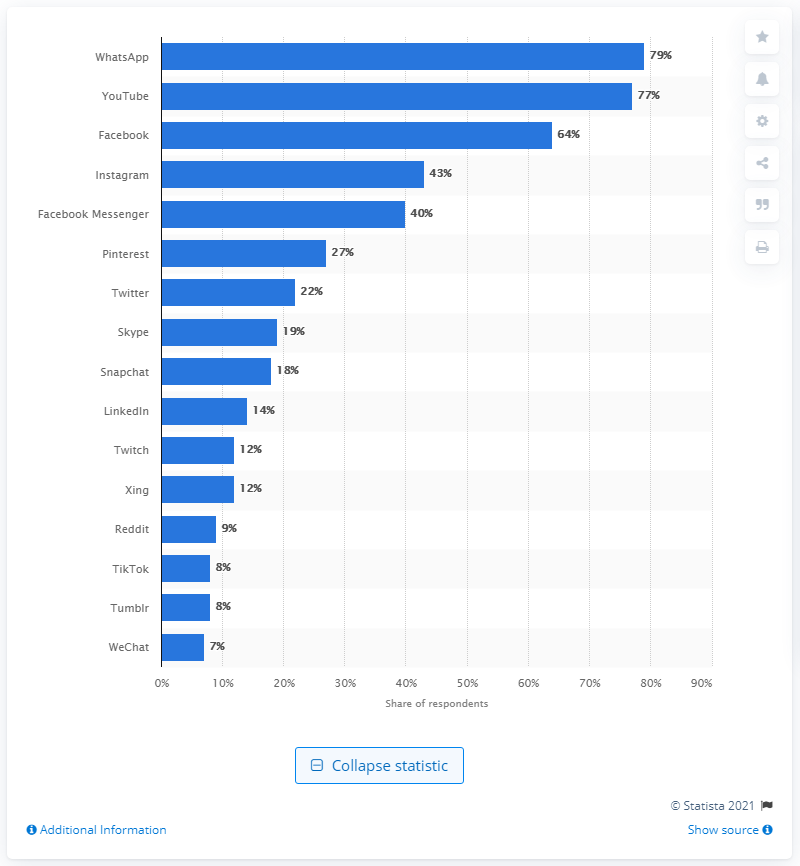Point out several critical features in this image. According to a survey, 79% of users in Germany confirmed that WhatsApp was the leading active social media platform in 2019. 